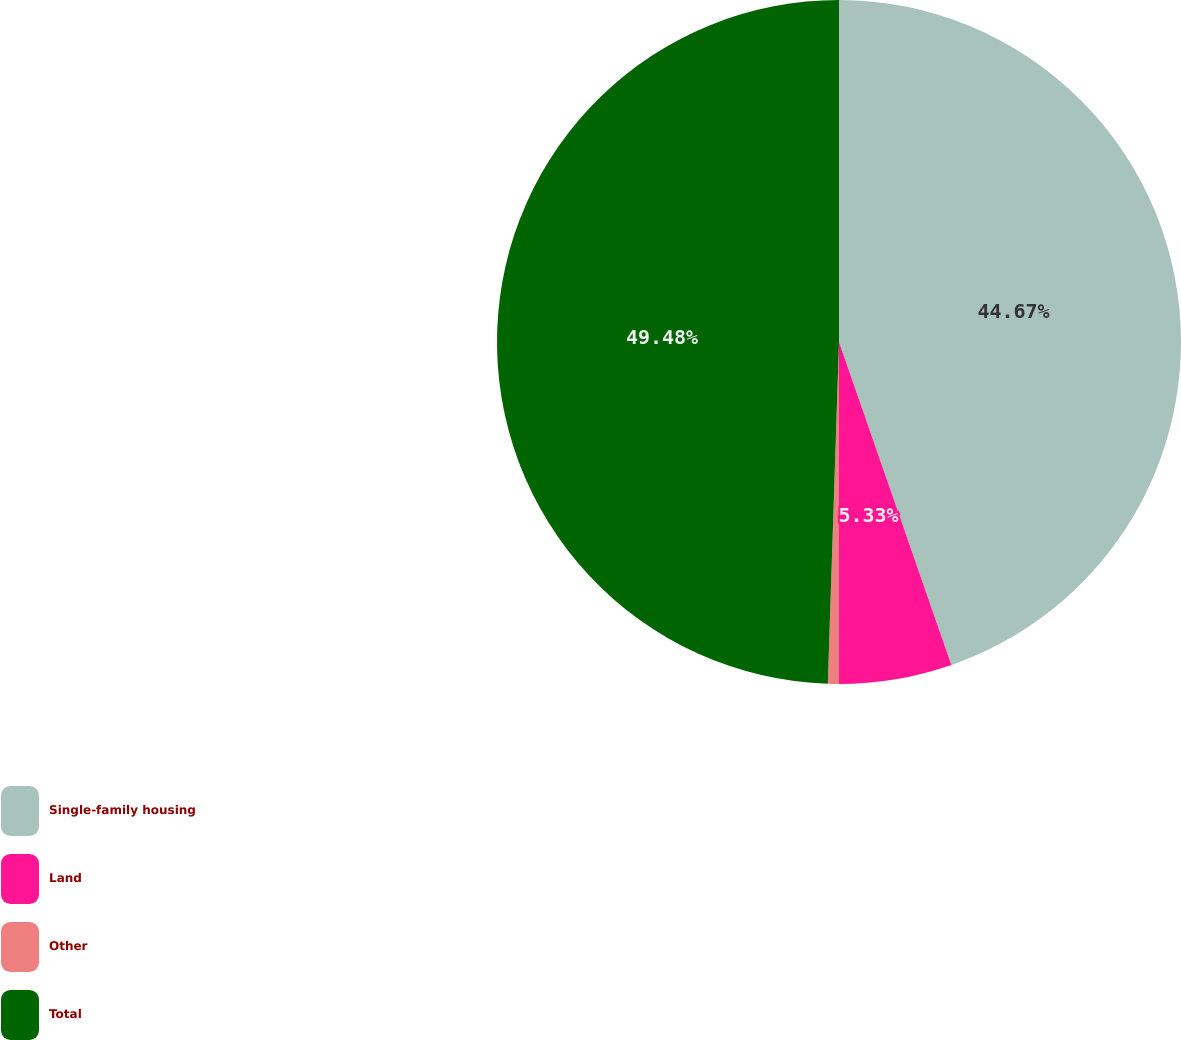Convert chart. <chart><loc_0><loc_0><loc_500><loc_500><pie_chart><fcel>Single-family housing<fcel>Land<fcel>Other<fcel>Total<nl><fcel>44.67%<fcel>5.33%<fcel>0.52%<fcel>49.48%<nl></chart> 